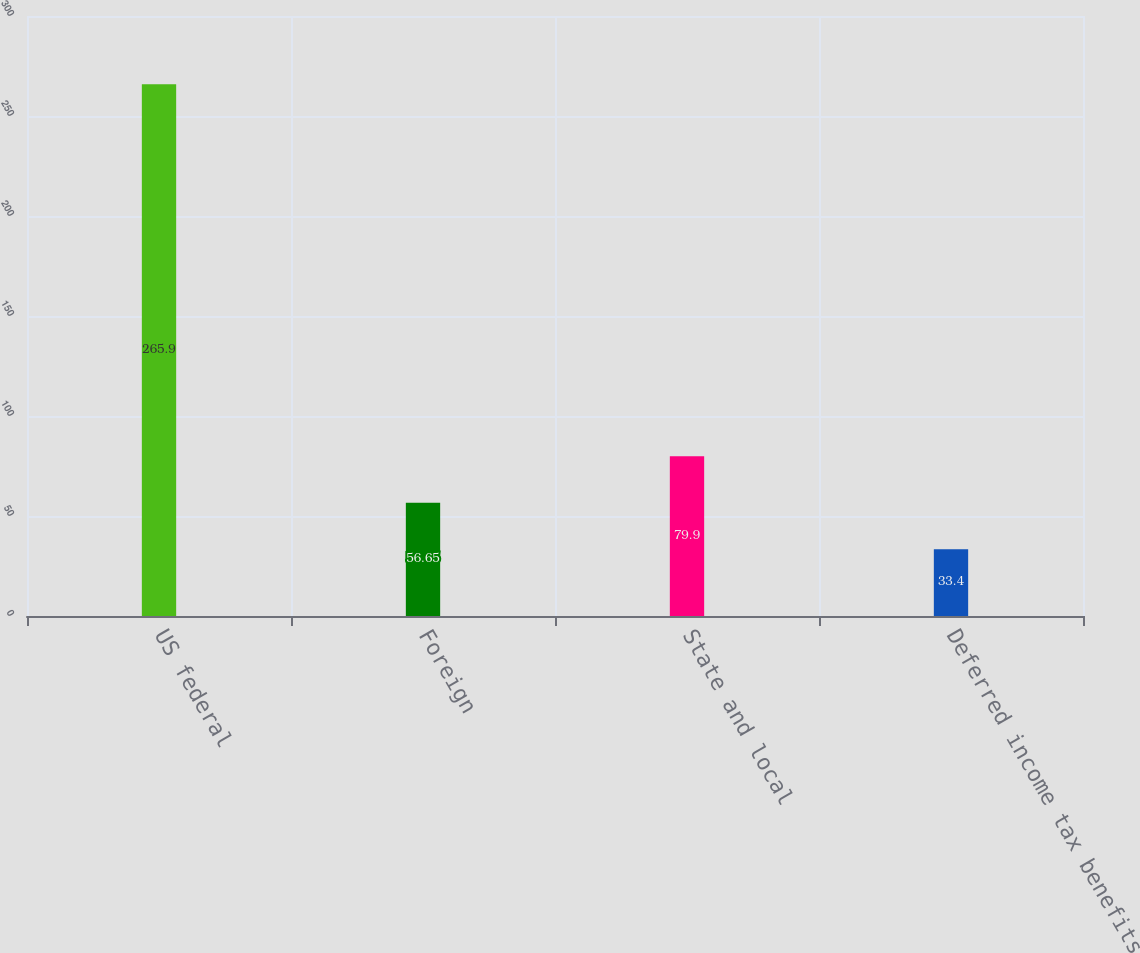<chart> <loc_0><loc_0><loc_500><loc_500><bar_chart><fcel>US federal<fcel>Foreign<fcel>State and local<fcel>Deferred income tax benefits<nl><fcel>265.9<fcel>56.65<fcel>79.9<fcel>33.4<nl></chart> 